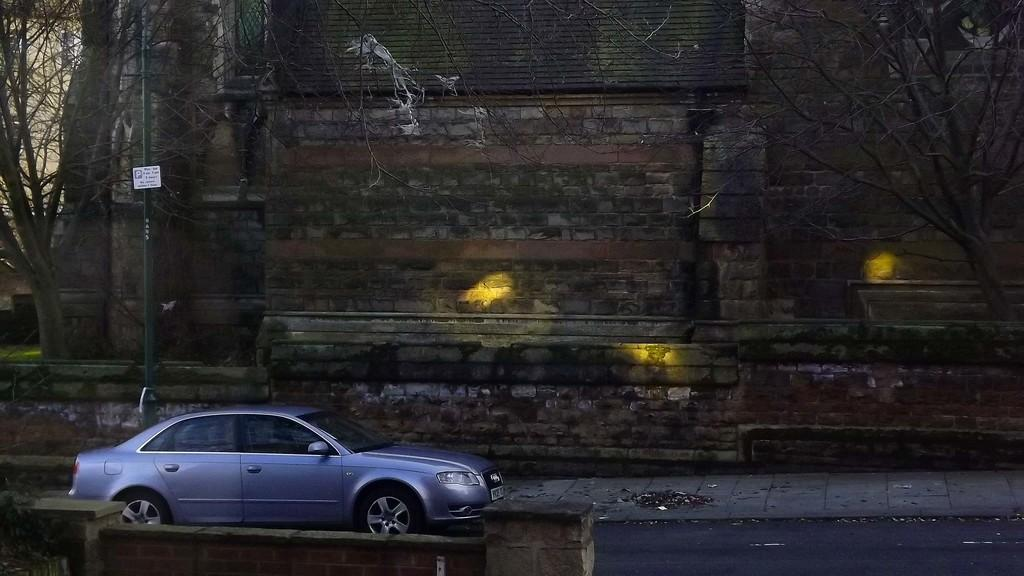What type of vehicle can be seen on the road in the image? There is a car on the road in the image. What structure is visible in the background of the image? There is a building wall in the image. What type of vegetation is present in the image? Trees with branches are visible in the image. What is attached to the pole in the image? There is a pole with a board attached to it in the image. How many dogs are sitting on the cake in the image? There is no cake or dogs present in the image. What type of snail can be seen crawling on the building wall in the image? There is no snail visible on the building wall in the image. 